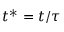<formula> <loc_0><loc_0><loc_500><loc_500>t ^ { * } = t / \tau</formula> 